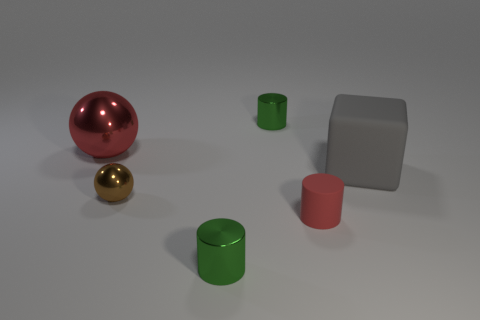How many objects are there in the image and can you describe their colors? There are five objects in the image. Starting from left to right, there is a metallic red sphere, a gold sphere, a green cylindrical object, a pink cylinder, and a matte grey cube. 